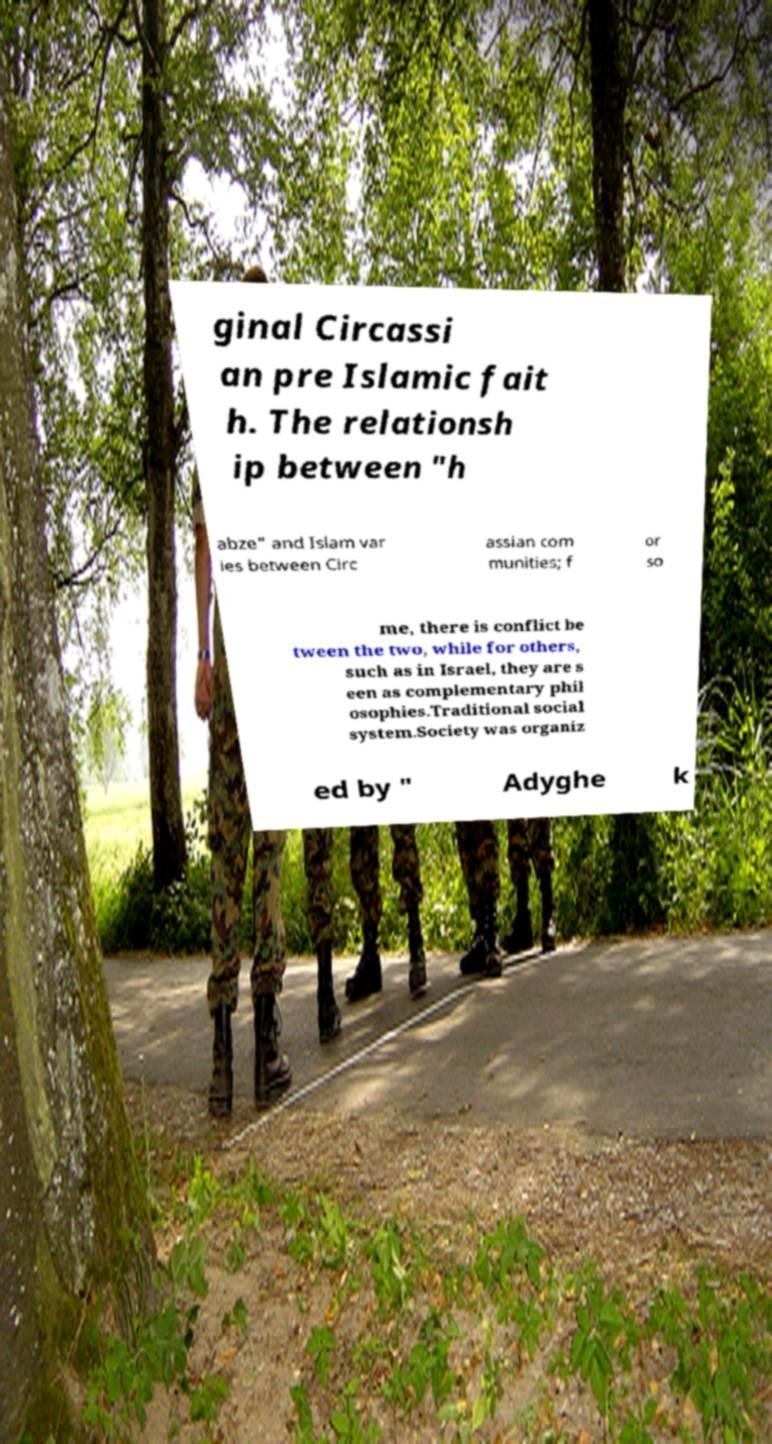What messages or text are displayed in this image? I need them in a readable, typed format. ginal Circassi an pre Islamic fait h. The relationsh ip between "h abze" and Islam var ies between Circ assian com munities; f or so me, there is conflict be tween the two, while for others, such as in Israel, they are s een as complementary phil osophies.Traditional social system.Society was organiz ed by " Adyghe k 